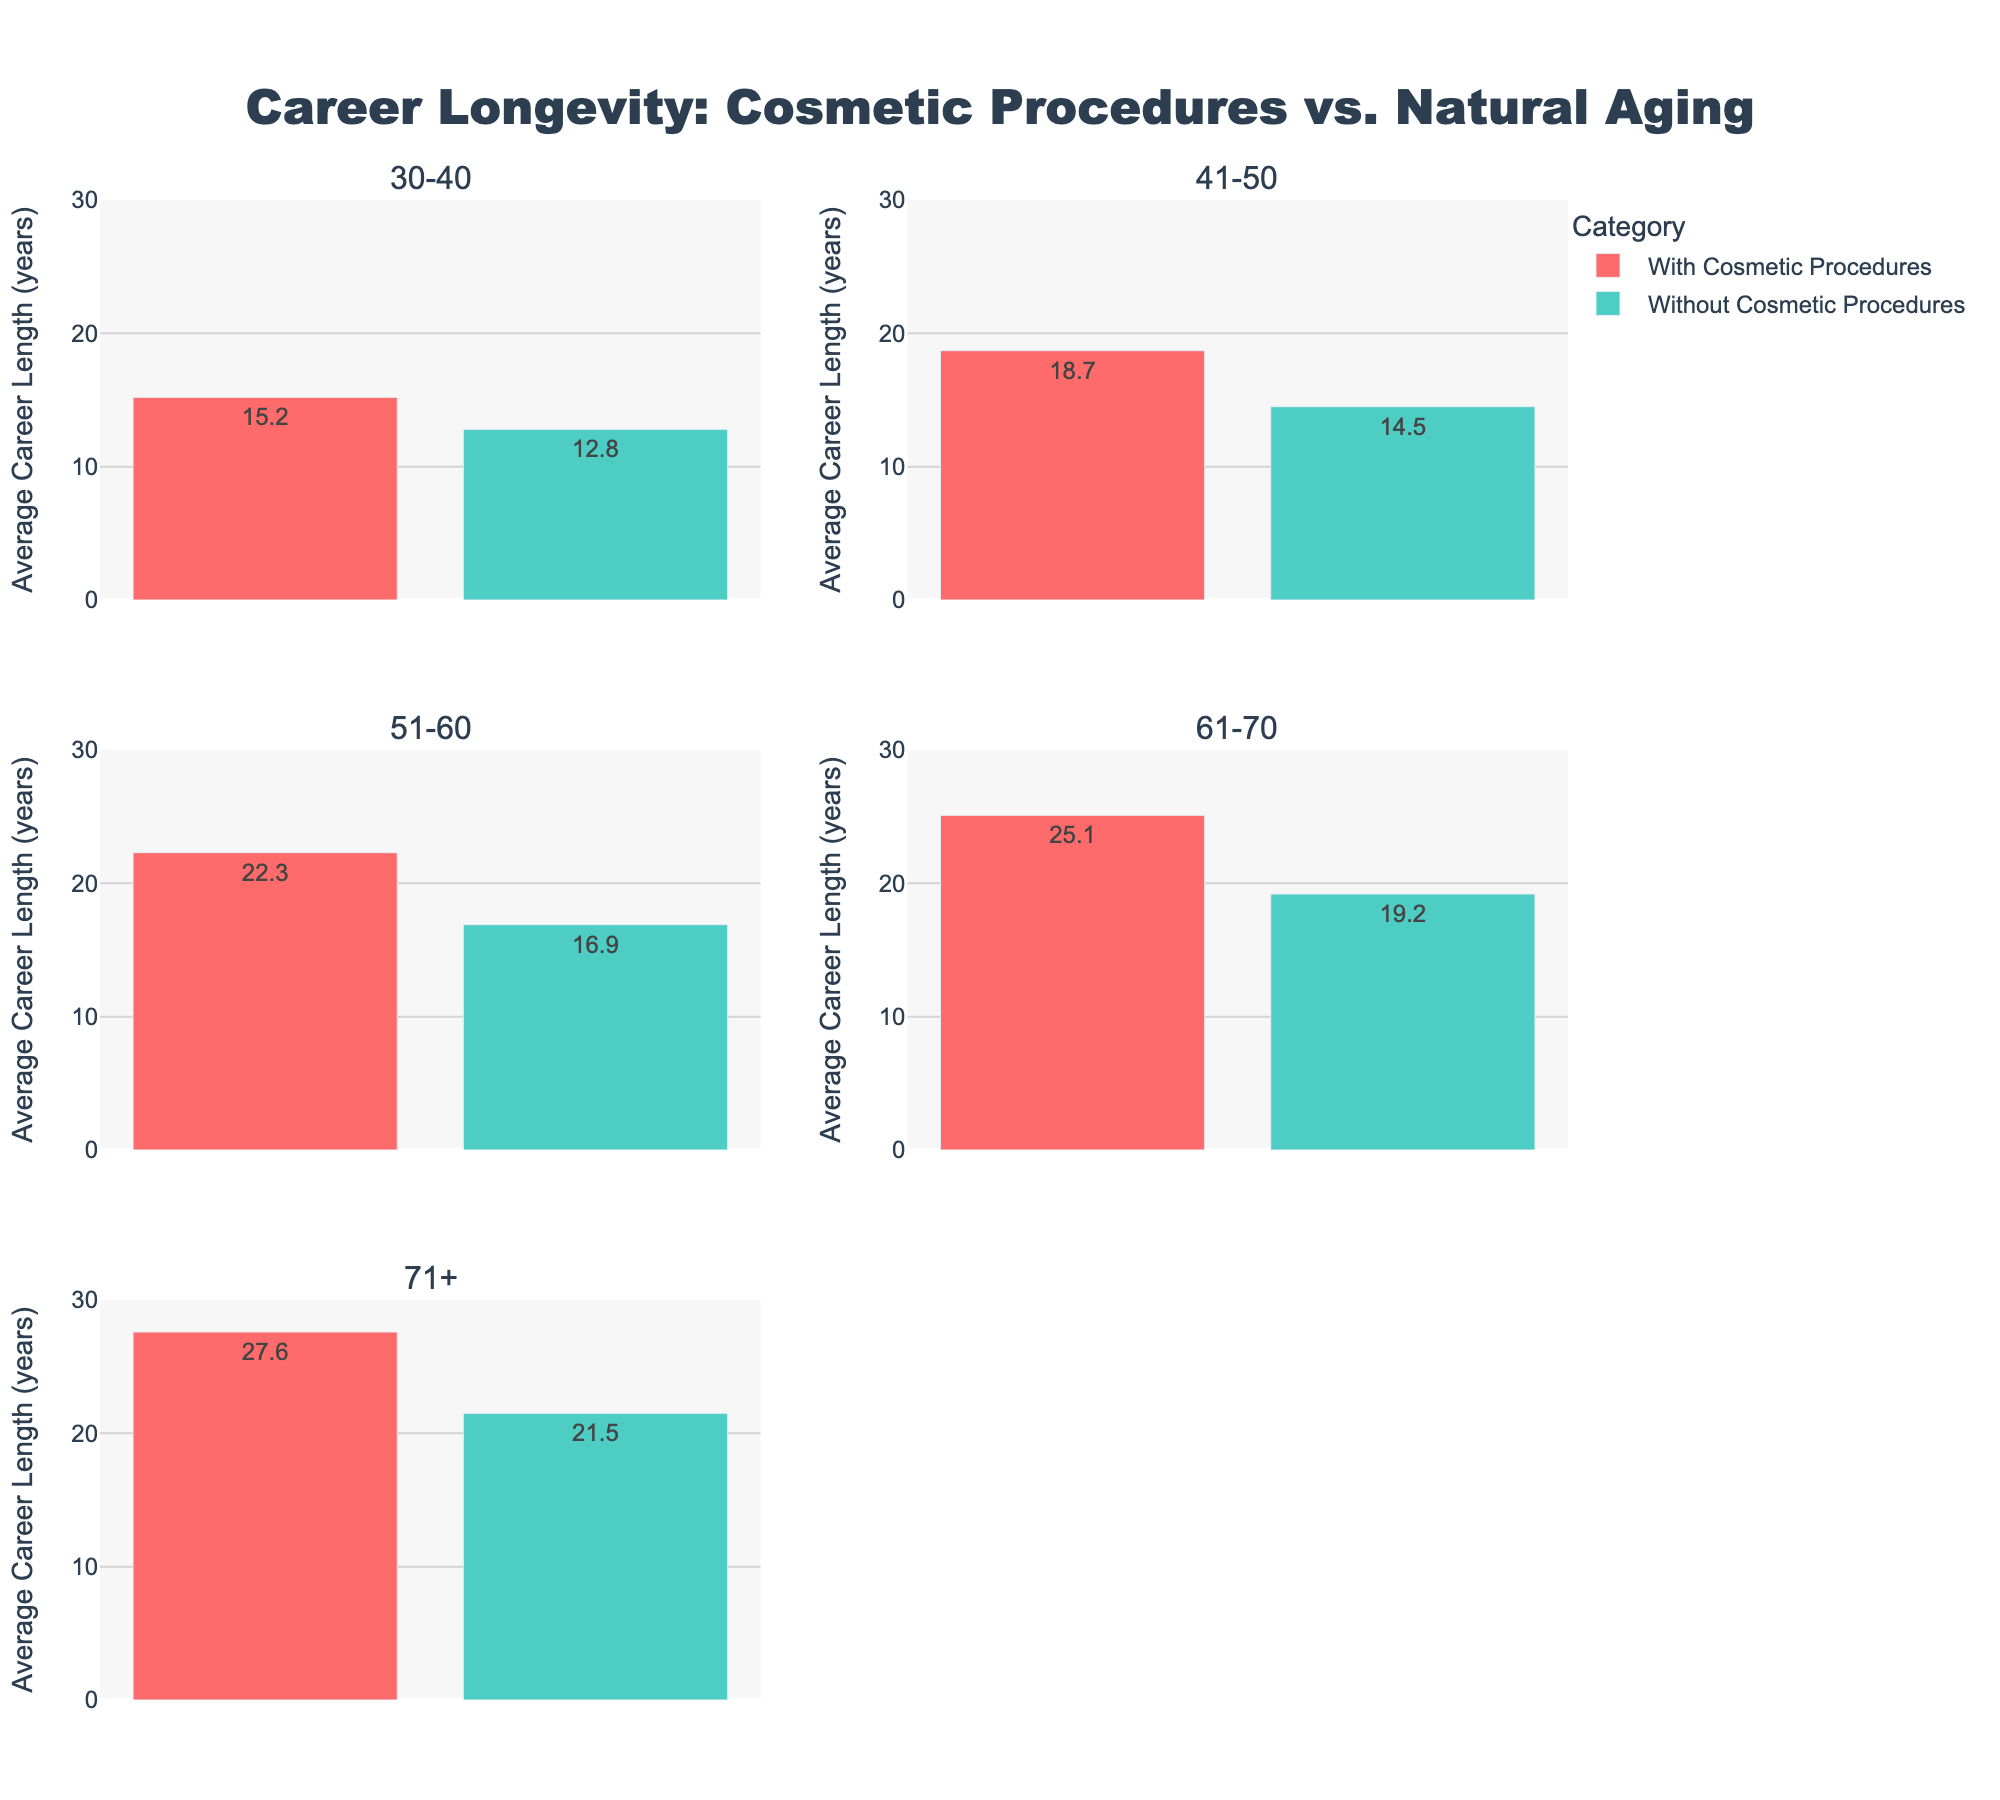What is the title of the figure? The title is typically found at the top of the figure. In this case, it is centered and formatted to be easily noticeable.
Answer: Career Longevity: Cosmetic Procedures vs. Natural Aging How many age categories are analyzed in the figure? The figure has subplots, each titled with a different age category. You can count the number of subplots to find the total number of age categories.
Answer: 5 What is the average career length for actors aged 51-60 who have undergone cosmetic procedures? Look at the subplot titled "51-60". In this subplot, find the bar for "With Cosmetic Procedures" and read the value displayed.
Answer: 22.3 years In which age category is the difference in career length between actors with and without cosmetic procedures the greatest? For each age category, calculate the difference between the average career lengths of actors with and without cosmetic procedures. Compare these differences to determine the greatest one.
Answer: 61-70 How does the career length of actors aged 71+ who have undergone cosmetic procedures compare to those aged 30-40 without cosmetic procedures? Find the average career lengths for actors aged 71+ with cosmetic procedures and aged 30-40 without cosmetic procedures. Compare the two values.
Answer: Greater by 14.8 years (27.6 vs. 12.8) What is the average career length for actors in their 30s without cosmetic procedures? Look at the subplot titled "30-40". In this subplot, find the bar for "Without Cosmetic Procedures" and read the value displayed.
Answer: 12.8 years Are actors who underwent cosmetic procedures consistently having longer careers across all age categories? Compare the average career lengths for actors with and without cosmetic procedures in each age category. Check if the "With Cosmetic Procedures" bars are consistently taller.
Answer: Yes Which age category shows the smallest increase in career longevity due to cosmetic procedures? For each age category, calculate the increase in career length by subtracting the average career length for "Without Cosmetic Procedures" from "With Cosmetic Procedures". Find the smallest increase.
Answer: 30-40 (2.4 years) Is there any age category where actors without cosmetic procedures have a longer average career length than those with procedures? Compare the average career lengths for each age category. If any "Without Cosmetic Procedures" bar is taller, indicate the category.
Answer: No 